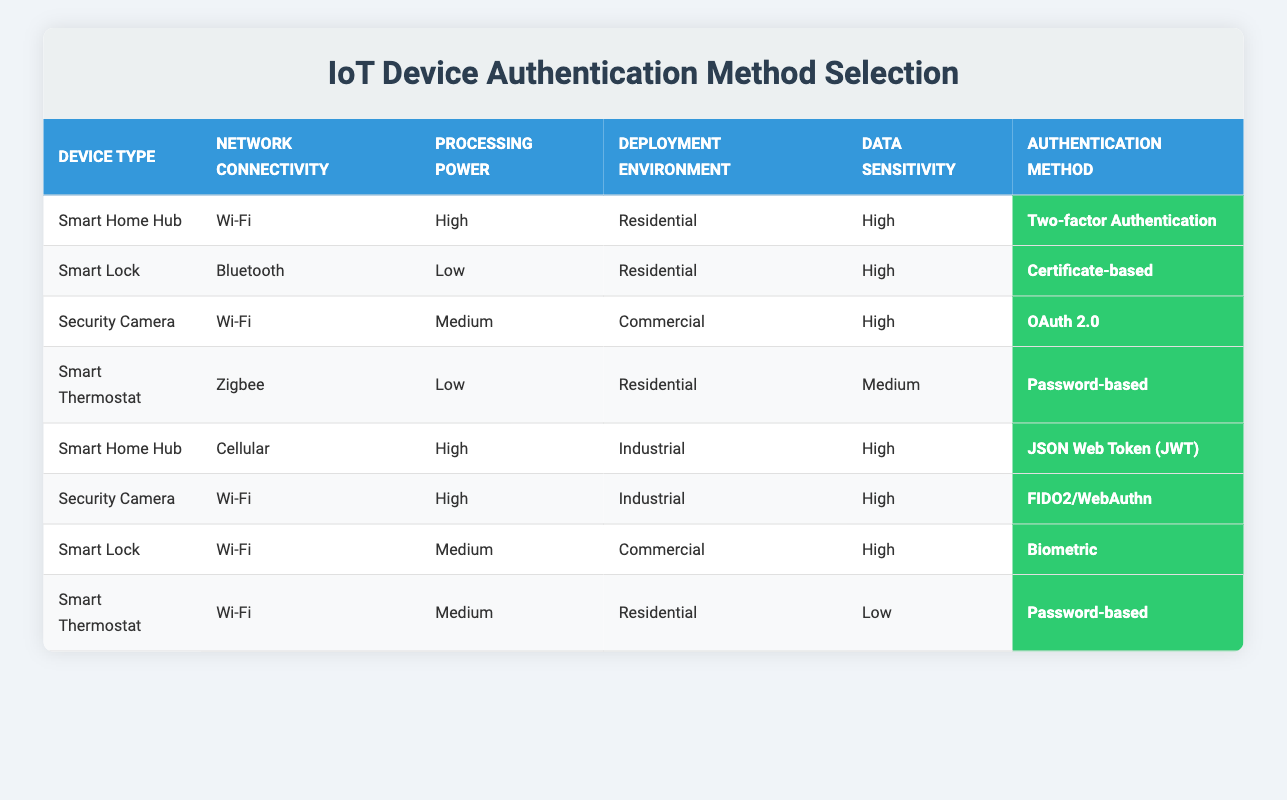What authentication method is recommended for a Smart Home Hub with High Processing Power in a Residential environment and High Data Sensitivity? The table shows that for a Smart Home Hub with high processing power, residential deployment, and high data sensitivity, the recommended authentication method is Two-factor Authentication. This is found in the first row of the table.
Answer: Two-factor Authentication Which device type uses Certificate-based authentication? From the table, the device type that uses Certificate-based authentication is the Smart Lock. This can be found by looking for the authentication method in the table.
Answer: Smart Lock Is Password-based authentication suggested for a Smart Thermostat with Low Data Sensitivity? According to the table, the Smart Thermostat with Wi-Fi connection, Medium Processing Power, Residential deployment, and Low Data Sensitivity does use Password-based authentication. Therefore, the answer is yes.
Answer: Yes What is the authentication method for a Security Camera deployed in an Industrial environment with High Data Sensitivity? The table shows that for a Security Camera with Wi-Fi connectivity, High Processing Power, Industrial deployment, and High Data Sensitivity, the authentication method recommended is FIDO2/WebAuthn, as listed in the sixth row of the table.
Answer: FIDO2/WebAuthn How many authentication methods are listed in the table? The table includes a total of seven authentication methods. Counting them from the actions section, we list Password-based, Two-factor Authentication, Certificate-based, Biometric, OAuth 2.0, JSON Web Token (JWT), and FIDO2/WebAuthn. Therefore, the total is seven.
Answer: Seven Which authentication method is not used for a Smart Lock in any environment? Reviewing the table, we see that the Smart Lock does not utilize OAuth 2.0 as an authentication method in any of the listed conditions. By scanning the rules, this option is absent for Smart Lock configurations.
Answer: OAuth 2.0 What is the recommended authentication method for a Smart Thermostat with High Data Sensitivity? The table indicates that a Smart Thermostat with Low Processing Power, Residential deployment, and Medium Data Sensitivity uses Password-based authentication. However, it does not recommend a method for a Smart Thermostat specifically identified with High Data Sensitivity conditions. Thus, it is concluded that no method is available under these specific parameters.
Answer: None For all Smart Home Hubs listed, how many different authentication methods are applied? The table lists two authentication methods for Smart Home Hubs, which are Two-factor Authentication for residential deployment with high data sensitivity and JSON Web Token (JWT) for industrial deployment with high data sensitivity. Hence, two different methods are applied in total across different conditions outlined for Smart Home Hubs.
Answer: Two 